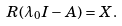Convert formula to latex. <formula><loc_0><loc_0><loc_500><loc_500>R ( \lambda _ { 0 } I - A ) = X .</formula> 